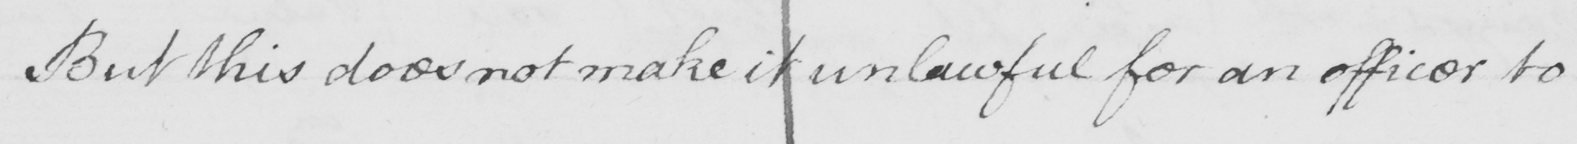What is written in this line of handwriting? But this does not make it unlawful for an officer to 